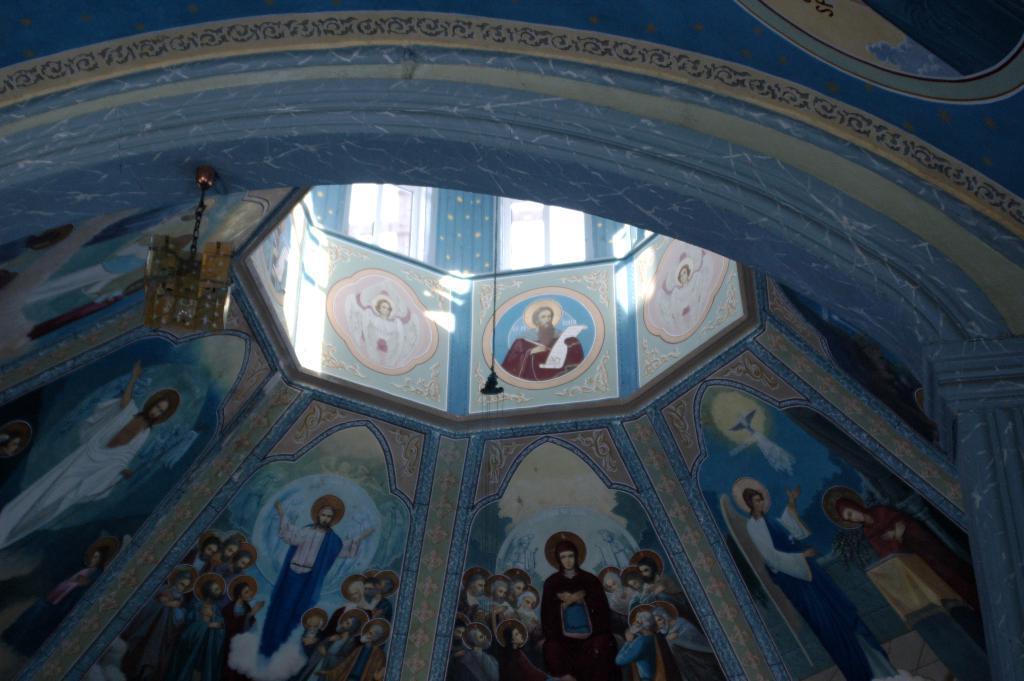Describe this image in one or two sentences. Here in this picture we can see an interior view of a building and on the walls we can see pictures of Jesus and other people present and we can see lights hanging over there and we can also see windows on the building. 